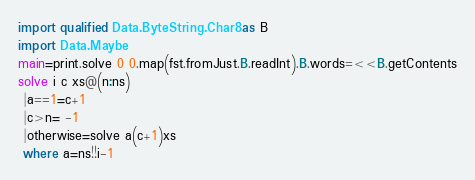Convert code to text. <code><loc_0><loc_0><loc_500><loc_500><_Haskell_>import qualified Data.ByteString.Char8 as B
import Data.Maybe
main=print.solve 0 0.map(fst.fromJust.B.readInt).B.words=<<B.getContents
solve i c xs@(n:ns)
 |a==1=c+1
 |c>n= -1
 |otherwise=solve a(c+1)xs
 where a=ns!!i-1</code> 